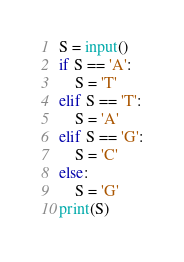Convert code to text. <code><loc_0><loc_0><loc_500><loc_500><_Python_>S = input()
if S == 'A':
    S = 'T'
elif S == 'T':
    S = 'A'
elif S == 'G':
    S = 'C'
else:
    S = 'G'
print(S)
</code> 